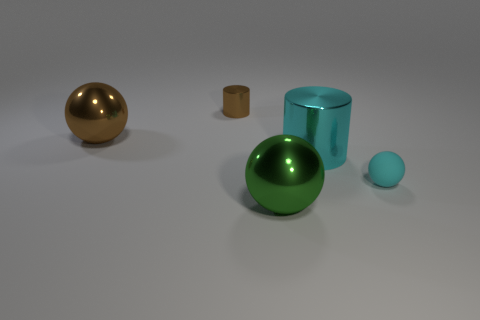Subtract all blue spheres. Subtract all red blocks. How many spheres are left? 3 Add 5 tiny blue metallic cylinders. How many objects exist? 10 Subtract all cylinders. How many objects are left? 3 Add 4 large cyan metallic cylinders. How many large cyan metallic cylinders exist? 5 Subtract 0 red cylinders. How many objects are left? 5 Subtract all cyan objects. Subtract all small brown metallic cubes. How many objects are left? 3 Add 5 green balls. How many green balls are left? 6 